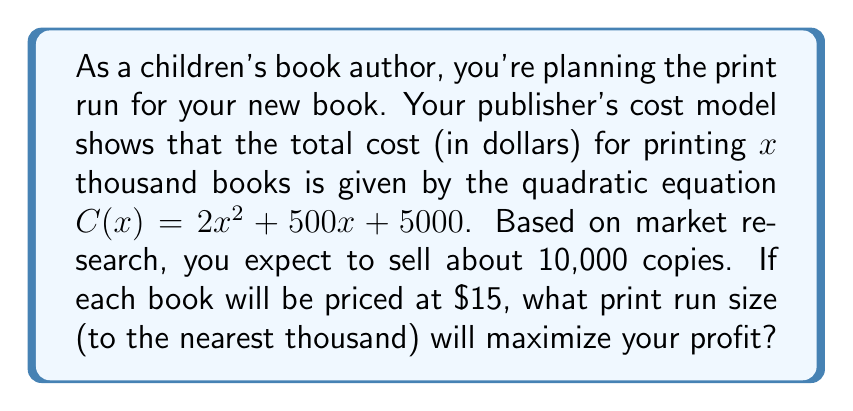Give your solution to this math problem. Let's approach this step-by-step:

1) First, we need to set up the profit function. Profit is revenue minus cost.

   Revenue = Price per book × Number of books sold
   $R(x) = 15 \times 10x = 150x$ (since $x$ is in thousands)

   Cost is given by $C(x) = 2x^2 + 500x + 5000$

   Profit $P(x) = R(x) - C(x) = 150x - (2x^2 + 500x + 5000)$

2) Simplify the profit function:
   $P(x) = 150x - 2x^2 - 500x - 5000$
   $P(x) = -2x^2 - 350x - 5000$

3) To find the maximum profit, we need to find the vertex of this parabola. The x-coordinate of the vertex will give us the optimal print run size.

4) For a quadratic function in the form $ax^2 + bx + c$, the x-coordinate of the vertex is given by $-\frac{b}{2a}$.

   Here, $a = -2$, $b = -350$

   $x = -\frac{-350}{2(-2)} = -\frac{-350}{-4} = \frac{350}{4} = 87.5$

5) Since we need to round to the nearest thousand, and 87.5 thousand is closer to 88 thousand than 87 thousand, our optimal print run size is 88,000 books.
Answer: 88,000 books 